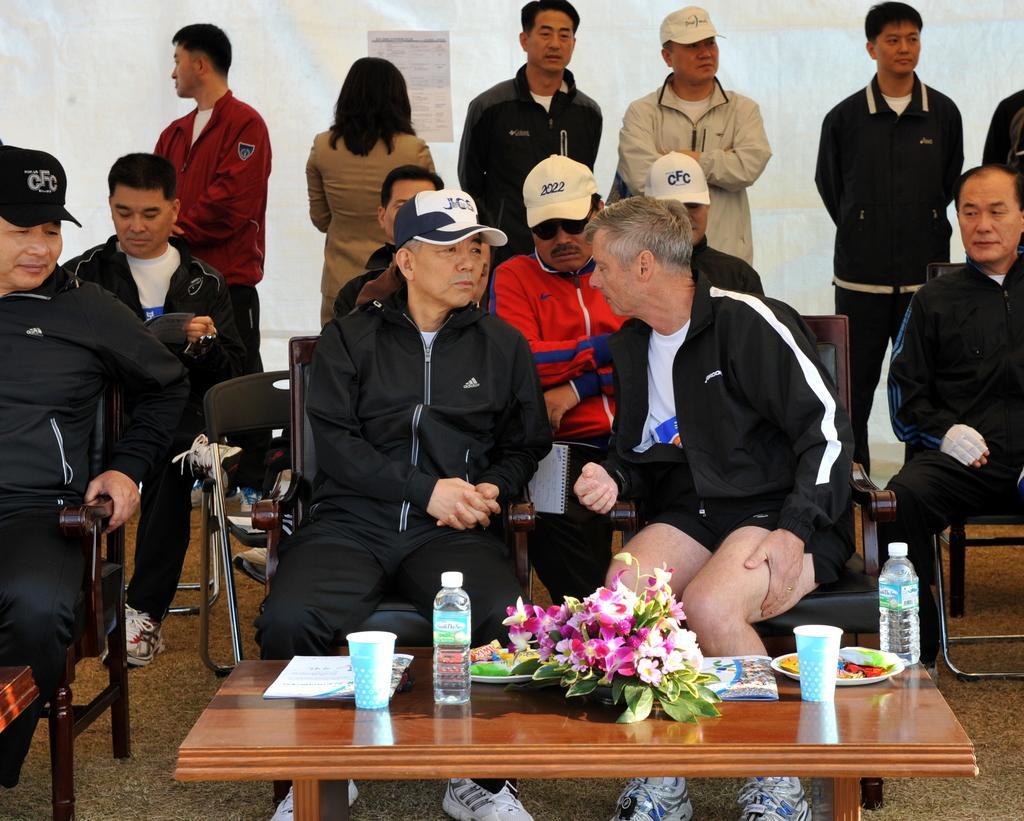Can you describe this image briefly? In this image there are glasses, bottles, cards,food items on the plates, flowers on the table, there are group of people standing and sitting on the chairs. 